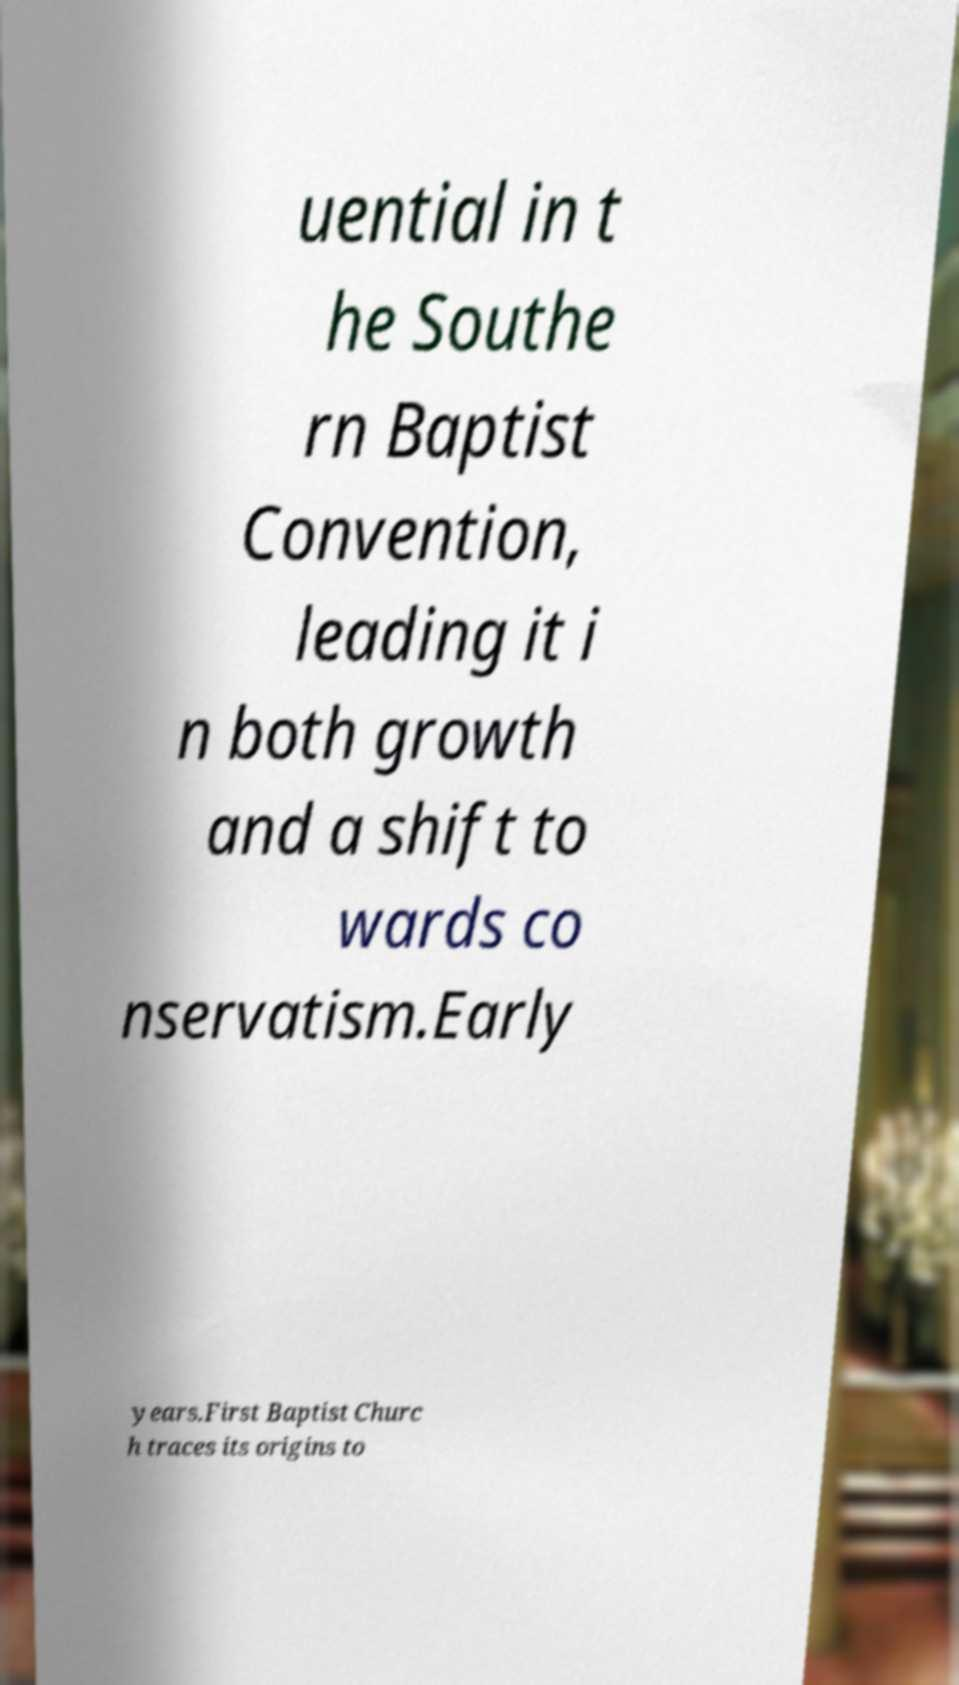Can you read and provide the text displayed in the image?This photo seems to have some interesting text. Can you extract and type it out for me? uential in t he Southe rn Baptist Convention, leading it i n both growth and a shift to wards co nservatism.Early years.First Baptist Churc h traces its origins to 